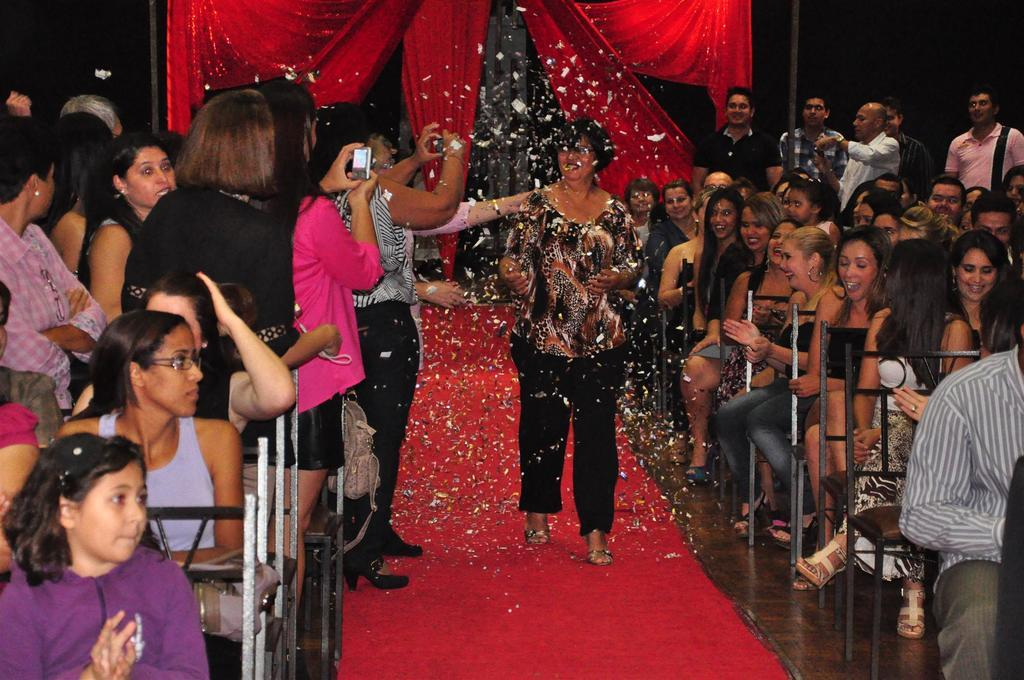What are the people in the image doing? The people in the image are sitting on chairs and standing on the floor. What can be seen in the background of the image? There are poles and curtains in the background of the image. What type of lamp can be seen hanging from the tail of the elephant in the image? There is no lamp or elephant present in the image. 